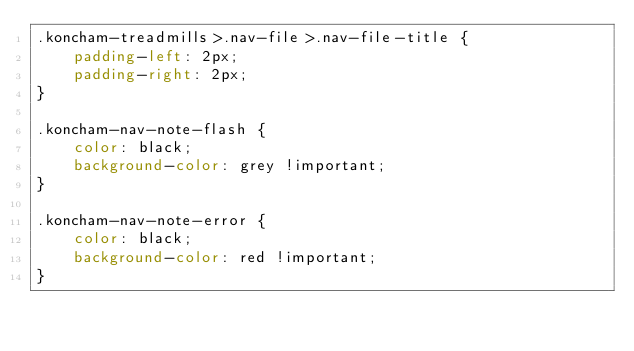<code> <loc_0><loc_0><loc_500><loc_500><_CSS_>.koncham-treadmills>.nav-file>.nav-file-title {
    padding-left: 2px;
    padding-right: 2px;
}

.koncham-nav-note-flash {
    color: black;
    background-color: grey !important;
}

.koncham-nav-note-error {
    color: black;
    background-color: red !important;
}</code> 